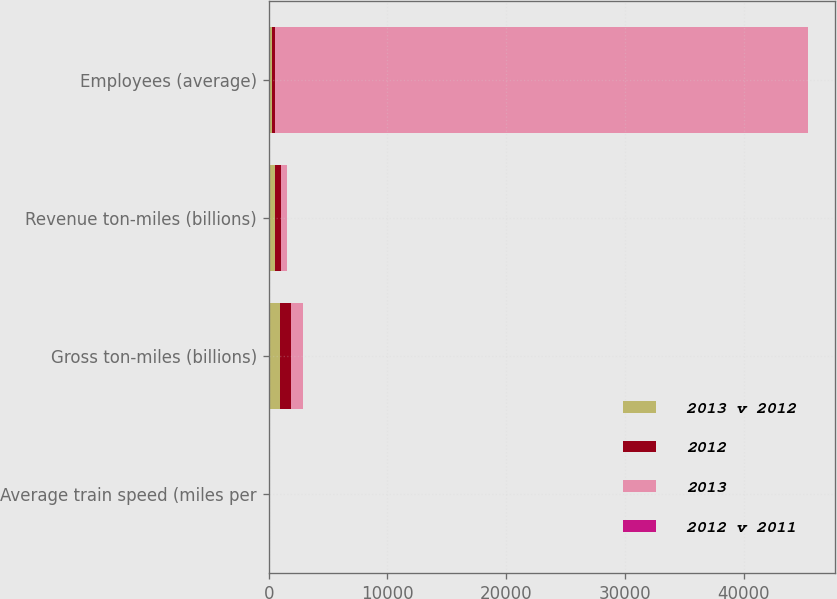Convert chart to OTSL. <chart><loc_0><loc_0><loc_500><loc_500><stacked_bar_chart><ecel><fcel>Average train speed (miles per<fcel>Gross ton-miles (billions)<fcel>Revenue ton-miles (billions)<fcel>Employees (average)<nl><fcel>2013 v 2012<fcel>26<fcel>949.1<fcel>514.3<fcel>270.4<nl><fcel>2012<fcel>26.5<fcel>959.3<fcel>521.1<fcel>270.4<nl><fcel>2013<fcel>25.6<fcel>978.2<fcel>544.4<fcel>44861<nl><fcel>2012 v 2011<fcel>2<fcel>1<fcel>1<fcel>1<nl></chart> 